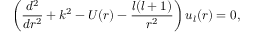<formula> <loc_0><loc_0><loc_500><loc_500>\left ( \frac { d ^ { 2 } } { d r ^ { 2 } } + k ^ { 2 } - U ( r ) - \frac { l ( l + 1 ) } { r ^ { 2 } } \right ) u _ { l } ( r ) = 0 ,</formula> 